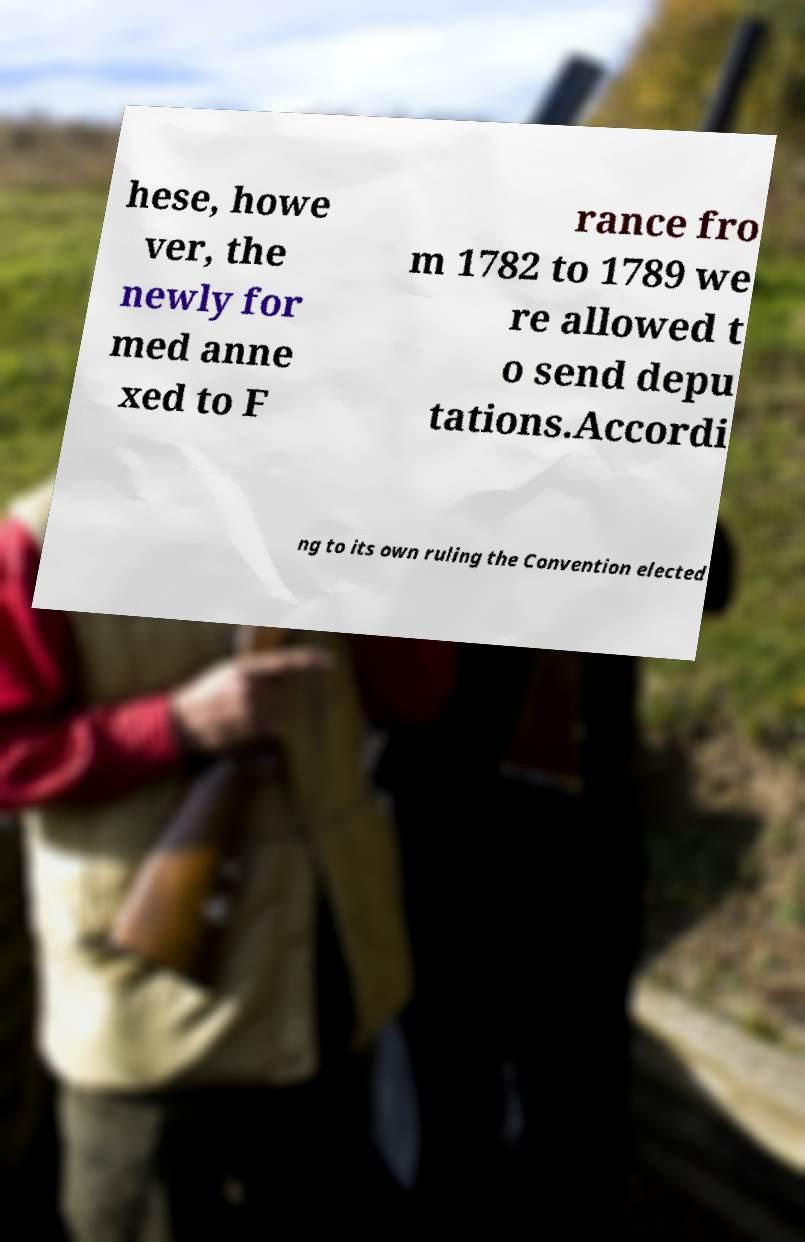Please read and relay the text visible in this image. What does it say? hese, howe ver, the newly for med anne xed to F rance fro m 1782 to 1789 we re allowed t o send depu tations.Accordi ng to its own ruling the Convention elected 